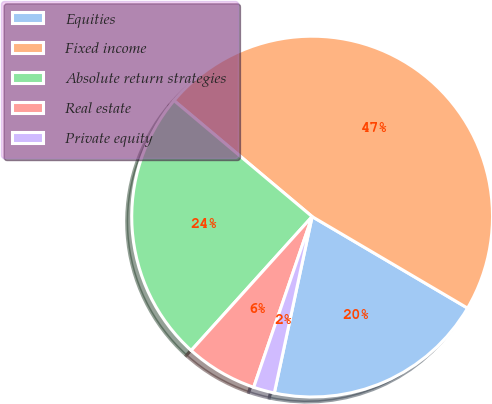Convert chart to OTSL. <chart><loc_0><loc_0><loc_500><loc_500><pie_chart><fcel>Equities<fcel>Fixed income<fcel>Absolute return strategies<fcel>Real estate<fcel>Private equity<nl><fcel>19.89%<fcel>47.35%<fcel>24.43%<fcel>6.44%<fcel>1.89%<nl></chart> 